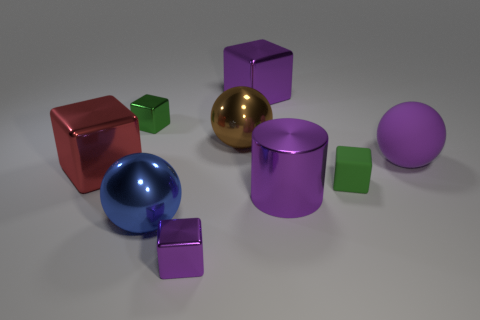How many green matte cubes are in front of the green rubber object? 0 